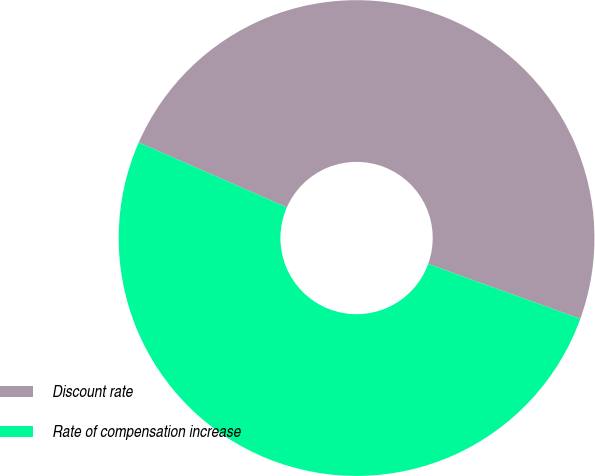Convert chart. <chart><loc_0><loc_0><loc_500><loc_500><pie_chart><fcel>Discount rate<fcel>Rate of compensation increase<nl><fcel>48.94%<fcel>51.06%<nl></chart> 